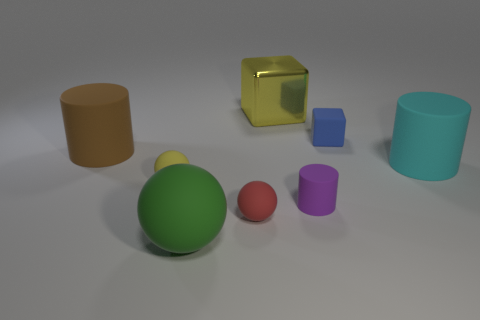Add 1 brown rubber objects. How many objects exist? 9 Subtract all blocks. How many objects are left? 6 Subtract all large spheres. Subtract all tiny blue blocks. How many objects are left? 6 Add 8 purple rubber objects. How many purple rubber objects are left? 9 Add 2 large green matte spheres. How many large green matte spheres exist? 3 Subtract 0 purple spheres. How many objects are left? 8 